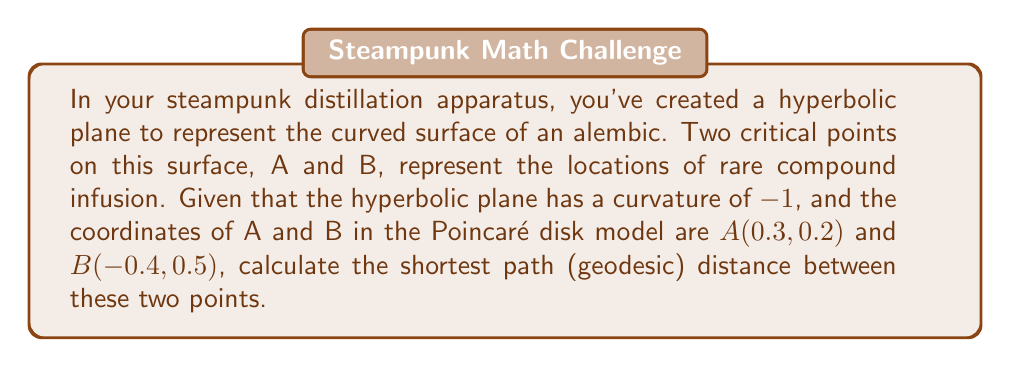Provide a solution to this math problem. Let's approach this step-by-step:

1) In the Poincaré disk model of hyperbolic geometry, the distance between two points is given by the formula:

   $$d = \text{arcosh}\left(1 + \frac{2|z_1 - z_2|^2}{(1-|z_1|^2)(1-|z_2|^2)}\right)$$

   where $z_1$ and $z_2$ are the complex representations of the two points.

2) Convert the given coordinates to complex numbers:
   $z_1 = 0.3 + 0.2i$ (point A)
   $z_2 = -0.4 + 0.5i$ (point B)

3) Calculate $|z_1 - z_2|^2$:
   $$|z_1 - z_2|^2 = (0.3 - (-0.4))^2 + (0.2 - 0.5)^2 = 0.7^2 + (-0.3)^2 = 0.49 + 0.09 = 0.58$$

4) Calculate $|z_1|^2$ and $|z_2|^2$:
   $$|z_1|^2 = 0.3^2 + 0.2^2 = 0.13$$
   $$|z_2|^2 = (-0.4)^2 + 0.5^2 = 0.41$$

5) Now, let's substitute these values into our distance formula:

   $$d = \text{arcosh}\left(1 + \frac{2(0.58)}{(1-0.13)(1-0.41)}\right)$$

6) Simplify:
   $$d = \text{arcosh}\left(1 + \frac{1.16}{(0.87)(0.59)}\right) = \text{arcosh}\left(1 + \frac{1.16}{0.5133}\right) = \text{arcosh}(3.2602)$$

7) Calculate the final result:
   $$d \approx 1.8814$$

This value represents the shortest path distance between points A and B on the hyperbolic plane of your alembic surface.
Answer: $1.8814$ 